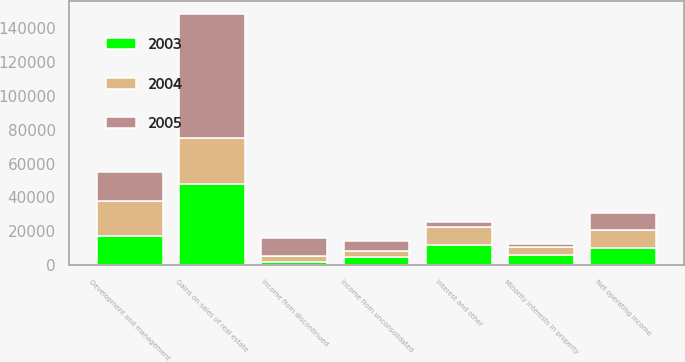Convert chart. <chart><loc_0><loc_0><loc_500><loc_500><stacked_bar_chart><ecel><fcel>Net operating income<fcel>Development and management<fcel>Interest and other<fcel>Minority interests in property<fcel>Income from unconsolidated<fcel>Gains on sales of real estate<fcel>Income from discontinued<nl><fcel>2003<fcel>10339<fcel>17310<fcel>12015<fcel>6017<fcel>4829<fcel>47656<fcel>1908<nl><fcel>2004<fcel>10339<fcel>20440<fcel>10339<fcel>4685<fcel>3380<fcel>27338<fcel>3344<nl><fcel>2005<fcel>10339<fcel>17332<fcel>3014<fcel>1827<fcel>6016<fcel>73234<fcel>10925<nl></chart> 